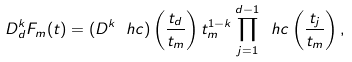Convert formula to latex. <formula><loc_0><loc_0><loc_500><loc_500>D _ { d } ^ { k } F _ { m } ( t ) = ( D ^ { k } \ h c ) \left ( \frac { t _ { d } } { t _ { m } } \right ) t _ { m } ^ { 1 - k } \prod _ { j = 1 } ^ { d - 1 } \ h c \left ( \frac { t _ { j } } { t _ { m } } \right ) ,</formula> 